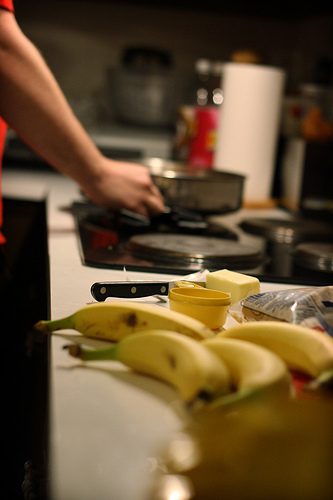Do you see both chairs and pots? I can see a pot in the image but no chairs are visible. 